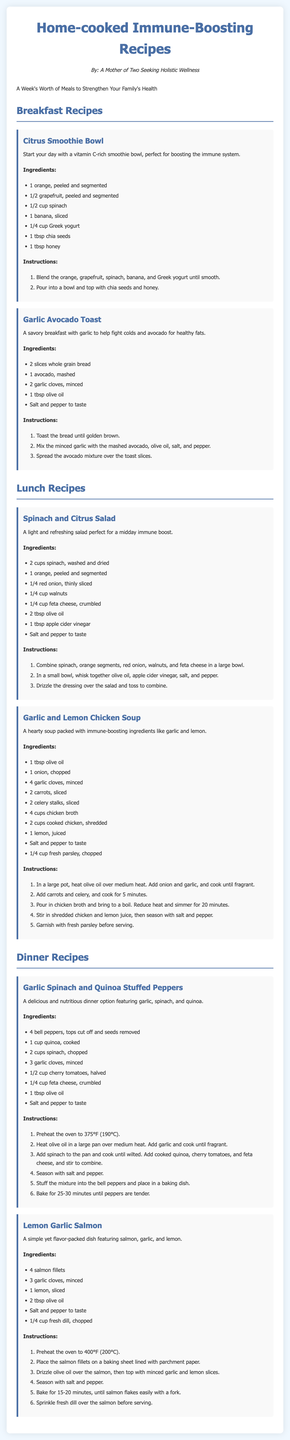What is the title of the document? The title of the document is presented in the header section and is "Home-cooked Immune-Boosting Recipes."
Answer: Home-cooked Immune-Boosting Recipes Who is the author of the document? The author is mentioned in the introduction section as "A Mother of Two Seeking Holistic Wellness."
Answer: A Mother of Two Seeking Holistic Wellness How many breakfast recipes are included? The document lists the breakfast recipes under their respective section, which shows there are two breakfast recipes.
Answer: 2 What is the main ingredient in the Citrus Smoothie Bowl? The main ingredients for the Citrus Smoothie Bowl can be found in the list; the primary fruit is orange.
Answer: Orange Which lunch recipe includes chicken? The lunch section includes a recipe for Garlic and Lemon Chicken Soup that specifically mentions chicken as an ingredient.
Answer: Garlic and Lemon Chicken Soup What cooking method is used for the Lemon Garlic Salmon? The document describes the preparation of the Lemon Garlic Salmon, which states that it is baked.
Answer: Baked How long should the Garlic Spinach and Quinoa Stuffed Peppers be baked? The cooking instructions for this recipe specify the baking time is 25-30 minutes.
Answer: 25-30 minutes What type of dish is the main focus of the document? The document is centered around recipes meant to strengthen the immune system through food, specifically home-cooked dishes.
Answer: Home-cooked dishes 